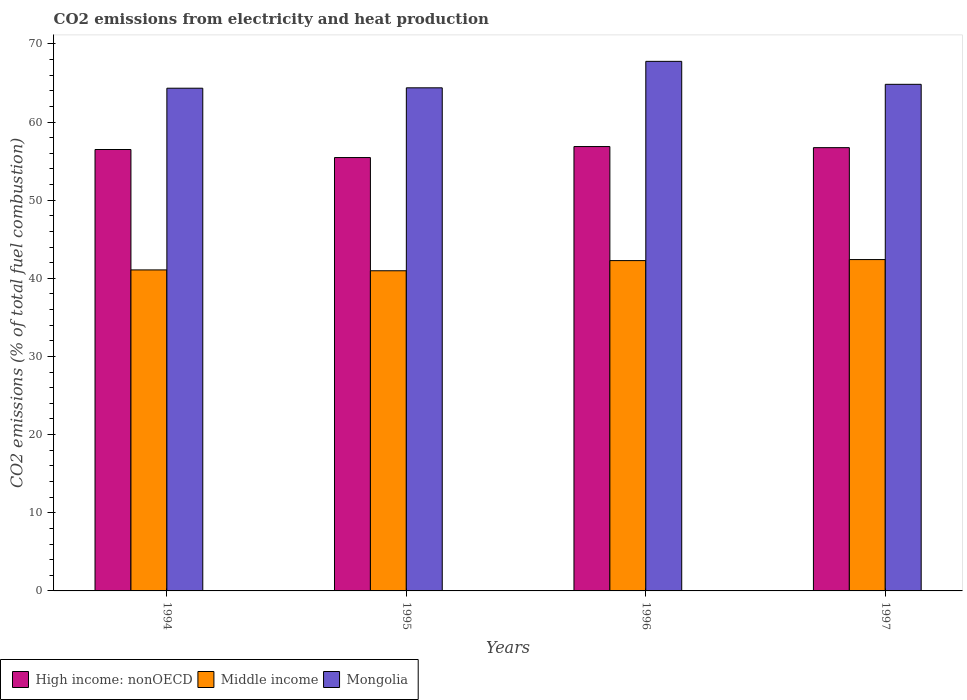Are the number of bars per tick equal to the number of legend labels?
Provide a short and direct response. Yes. Are the number of bars on each tick of the X-axis equal?
Provide a succinct answer. Yes. How many bars are there on the 2nd tick from the right?
Provide a succinct answer. 3. What is the label of the 1st group of bars from the left?
Give a very brief answer. 1994. In how many cases, is the number of bars for a given year not equal to the number of legend labels?
Your answer should be compact. 0. What is the amount of CO2 emitted in High income: nonOECD in 1997?
Give a very brief answer. 56.72. Across all years, what is the maximum amount of CO2 emitted in Mongolia?
Give a very brief answer. 67.76. Across all years, what is the minimum amount of CO2 emitted in Mongolia?
Give a very brief answer. 64.33. What is the total amount of CO2 emitted in Middle income in the graph?
Your response must be concise. 166.72. What is the difference between the amount of CO2 emitted in Middle income in 1994 and that in 1996?
Your answer should be compact. -1.19. What is the difference between the amount of CO2 emitted in High income: nonOECD in 1996 and the amount of CO2 emitted in Mongolia in 1995?
Give a very brief answer. -7.52. What is the average amount of CO2 emitted in Middle income per year?
Offer a very short reply. 41.68. In the year 1995, what is the difference between the amount of CO2 emitted in High income: nonOECD and amount of CO2 emitted in Mongolia?
Provide a short and direct response. -8.92. What is the ratio of the amount of CO2 emitted in Middle income in 1994 to that in 1996?
Offer a terse response. 0.97. Is the amount of CO2 emitted in Middle income in 1994 less than that in 1995?
Your answer should be compact. No. Is the difference between the amount of CO2 emitted in High income: nonOECD in 1995 and 1997 greater than the difference between the amount of CO2 emitted in Mongolia in 1995 and 1997?
Offer a terse response. No. What is the difference between the highest and the second highest amount of CO2 emitted in Middle income?
Offer a terse response. 0.13. What is the difference between the highest and the lowest amount of CO2 emitted in Middle income?
Give a very brief answer. 1.43. Is the sum of the amount of CO2 emitted in High income: nonOECD in 1996 and 1997 greater than the maximum amount of CO2 emitted in Middle income across all years?
Give a very brief answer. Yes. What does the 1st bar from the left in 1996 represents?
Your answer should be compact. High income: nonOECD. What does the 3rd bar from the right in 1997 represents?
Ensure brevity in your answer.  High income: nonOECD. What is the difference between two consecutive major ticks on the Y-axis?
Give a very brief answer. 10. Does the graph contain any zero values?
Your response must be concise. No. Does the graph contain grids?
Ensure brevity in your answer.  No. Where does the legend appear in the graph?
Your answer should be very brief. Bottom left. How are the legend labels stacked?
Offer a terse response. Horizontal. What is the title of the graph?
Offer a very short reply. CO2 emissions from electricity and heat production. Does "Macao" appear as one of the legend labels in the graph?
Provide a succinct answer. No. What is the label or title of the Y-axis?
Offer a very short reply. CO2 emissions (% of total fuel combustion). What is the CO2 emissions (% of total fuel combustion) of High income: nonOECD in 1994?
Keep it short and to the point. 56.48. What is the CO2 emissions (% of total fuel combustion) of Middle income in 1994?
Provide a succinct answer. 41.08. What is the CO2 emissions (% of total fuel combustion) of Mongolia in 1994?
Provide a succinct answer. 64.33. What is the CO2 emissions (% of total fuel combustion) in High income: nonOECD in 1995?
Make the answer very short. 55.45. What is the CO2 emissions (% of total fuel combustion) of Middle income in 1995?
Your response must be concise. 40.97. What is the CO2 emissions (% of total fuel combustion) of Mongolia in 1995?
Provide a succinct answer. 64.38. What is the CO2 emissions (% of total fuel combustion) of High income: nonOECD in 1996?
Offer a very short reply. 56.86. What is the CO2 emissions (% of total fuel combustion) in Middle income in 1996?
Your answer should be compact. 42.27. What is the CO2 emissions (% of total fuel combustion) in Mongolia in 1996?
Keep it short and to the point. 67.76. What is the CO2 emissions (% of total fuel combustion) of High income: nonOECD in 1997?
Ensure brevity in your answer.  56.72. What is the CO2 emissions (% of total fuel combustion) of Middle income in 1997?
Offer a terse response. 42.4. What is the CO2 emissions (% of total fuel combustion) in Mongolia in 1997?
Ensure brevity in your answer.  64.83. Across all years, what is the maximum CO2 emissions (% of total fuel combustion) in High income: nonOECD?
Your response must be concise. 56.86. Across all years, what is the maximum CO2 emissions (% of total fuel combustion) in Middle income?
Your response must be concise. 42.4. Across all years, what is the maximum CO2 emissions (% of total fuel combustion) of Mongolia?
Your answer should be compact. 67.76. Across all years, what is the minimum CO2 emissions (% of total fuel combustion) of High income: nonOECD?
Your response must be concise. 55.45. Across all years, what is the minimum CO2 emissions (% of total fuel combustion) in Middle income?
Make the answer very short. 40.97. Across all years, what is the minimum CO2 emissions (% of total fuel combustion) of Mongolia?
Offer a very short reply. 64.33. What is the total CO2 emissions (% of total fuel combustion) of High income: nonOECD in the graph?
Make the answer very short. 225.52. What is the total CO2 emissions (% of total fuel combustion) in Middle income in the graph?
Make the answer very short. 166.72. What is the total CO2 emissions (% of total fuel combustion) of Mongolia in the graph?
Offer a very short reply. 261.3. What is the difference between the CO2 emissions (% of total fuel combustion) of High income: nonOECD in 1994 and that in 1995?
Your answer should be compact. 1.03. What is the difference between the CO2 emissions (% of total fuel combustion) of Middle income in 1994 and that in 1995?
Your answer should be very brief. 0.11. What is the difference between the CO2 emissions (% of total fuel combustion) in High income: nonOECD in 1994 and that in 1996?
Provide a short and direct response. -0.38. What is the difference between the CO2 emissions (% of total fuel combustion) of Middle income in 1994 and that in 1996?
Ensure brevity in your answer.  -1.19. What is the difference between the CO2 emissions (% of total fuel combustion) in Mongolia in 1994 and that in 1996?
Keep it short and to the point. -3.44. What is the difference between the CO2 emissions (% of total fuel combustion) of High income: nonOECD in 1994 and that in 1997?
Provide a succinct answer. -0.24. What is the difference between the CO2 emissions (% of total fuel combustion) in Middle income in 1994 and that in 1997?
Make the answer very short. -1.32. What is the difference between the CO2 emissions (% of total fuel combustion) in Mongolia in 1994 and that in 1997?
Give a very brief answer. -0.5. What is the difference between the CO2 emissions (% of total fuel combustion) in High income: nonOECD in 1995 and that in 1996?
Provide a succinct answer. -1.41. What is the difference between the CO2 emissions (% of total fuel combustion) in Middle income in 1995 and that in 1996?
Provide a succinct answer. -1.3. What is the difference between the CO2 emissions (% of total fuel combustion) in Mongolia in 1995 and that in 1996?
Make the answer very short. -3.39. What is the difference between the CO2 emissions (% of total fuel combustion) of High income: nonOECD in 1995 and that in 1997?
Your answer should be very brief. -1.27. What is the difference between the CO2 emissions (% of total fuel combustion) in Middle income in 1995 and that in 1997?
Your answer should be very brief. -1.43. What is the difference between the CO2 emissions (% of total fuel combustion) of Mongolia in 1995 and that in 1997?
Your response must be concise. -0.45. What is the difference between the CO2 emissions (% of total fuel combustion) of High income: nonOECD in 1996 and that in 1997?
Ensure brevity in your answer.  0.14. What is the difference between the CO2 emissions (% of total fuel combustion) of Middle income in 1996 and that in 1997?
Give a very brief answer. -0.13. What is the difference between the CO2 emissions (% of total fuel combustion) of Mongolia in 1996 and that in 1997?
Offer a very short reply. 2.94. What is the difference between the CO2 emissions (% of total fuel combustion) of High income: nonOECD in 1994 and the CO2 emissions (% of total fuel combustion) of Middle income in 1995?
Provide a short and direct response. 15.52. What is the difference between the CO2 emissions (% of total fuel combustion) in High income: nonOECD in 1994 and the CO2 emissions (% of total fuel combustion) in Mongolia in 1995?
Ensure brevity in your answer.  -7.89. What is the difference between the CO2 emissions (% of total fuel combustion) in Middle income in 1994 and the CO2 emissions (% of total fuel combustion) in Mongolia in 1995?
Your answer should be compact. -23.3. What is the difference between the CO2 emissions (% of total fuel combustion) in High income: nonOECD in 1994 and the CO2 emissions (% of total fuel combustion) in Middle income in 1996?
Provide a succinct answer. 14.21. What is the difference between the CO2 emissions (% of total fuel combustion) of High income: nonOECD in 1994 and the CO2 emissions (% of total fuel combustion) of Mongolia in 1996?
Give a very brief answer. -11.28. What is the difference between the CO2 emissions (% of total fuel combustion) in Middle income in 1994 and the CO2 emissions (% of total fuel combustion) in Mongolia in 1996?
Make the answer very short. -26.69. What is the difference between the CO2 emissions (% of total fuel combustion) in High income: nonOECD in 1994 and the CO2 emissions (% of total fuel combustion) in Middle income in 1997?
Your answer should be very brief. 14.08. What is the difference between the CO2 emissions (% of total fuel combustion) of High income: nonOECD in 1994 and the CO2 emissions (% of total fuel combustion) of Mongolia in 1997?
Give a very brief answer. -8.34. What is the difference between the CO2 emissions (% of total fuel combustion) in Middle income in 1994 and the CO2 emissions (% of total fuel combustion) in Mongolia in 1997?
Ensure brevity in your answer.  -23.75. What is the difference between the CO2 emissions (% of total fuel combustion) of High income: nonOECD in 1995 and the CO2 emissions (% of total fuel combustion) of Middle income in 1996?
Give a very brief answer. 13.19. What is the difference between the CO2 emissions (% of total fuel combustion) of High income: nonOECD in 1995 and the CO2 emissions (% of total fuel combustion) of Mongolia in 1996?
Your answer should be compact. -12.31. What is the difference between the CO2 emissions (% of total fuel combustion) in Middle income in 1995 and the CO2 emissions (% of total fuel combustion) in Mongolia in 1996?
Ensure brevity in your answer.  -26.8. What is the difference between the CO2 emissions (% of total fuel combustion) in High income: nonOECD in 1995 and the CO2 emissions (% of total fuel combustion) in Middle income in 1997?
Provide a short and direct response. 13.05. What is the difference between the CO2 emissions (% of total fuel combustion) in High income: nonOECD in 1995 and the CO2 emissions (% of total fuel combustion) in Mongolia in 1997?
Your answer should be compact. -9.37. What is the difference between the CO2 emissions (% of total fuel combustion) in Middle income in 1995 and the CO2 emissions (% of total fuel combustion) in Mongolia in 1997?
Your response must be concise. -23.86. What is the difference between the CO2 emissions (% of total fuel combustion) in High income: nonOECD in 1996 and the CO2 emissions (% of total fuel combustion) in Middle income in 1997?
Keep it short and to the point. 14.46. What is the difference between the CO2 emissions (% of total fuel combustion) in High income: nonOECD in 1996 and the CO2 emissions (% of total fuel combustion) in Mongolia in 1997?
Give a very brief answer. -7.96. What is the difference between the CO2 emissions (% of total fuel combustion) in Middle income in 1996 and the CO2 emissions (% of total fuel combustion) in Mongolia in 1997?
Provide a succinct answer. -22.56. What is the average CO2 emissions (% of total fuel combustion) in High income: nonOECD per year?
Offer a very short reply. 56.38. What is the average CO2 emissions (% of total fuel combustion) of Middle income per year?
Offer a very short reply. 41.68. What is the average CO2 emissions (% of total fuel combustion) in Mongolia per year?
Provide a short and direct response. 65.32. In the year 1994, what is the difference between the CO2 emissions (% of total fuel combustion) of High income: nonOECD and CO2 emissions (% of total fuel combustion) of Middle income?
Make the answer very short. 15.41. In the year 1994, what is the difference between the CO2 emissions (% of total fuel combustion) of High income: nonOECD and CO2 emissions (% of total fuel combustion) of Mongolia?
Keep it short and to the point. -7.84. In the year 1994, what is the difference between the CO2 emissions (% of total fuel combustion) of Middle income and CO2 emissions (% of total fuel combustion) of Mongolia?
Give a very brief answer. -23.25. In the year 1995, what is the difference between the CO2 emissions (% of total fuel combustion) in High income: nonOECD and CO2 emissions (% of total fuel combustion) in Middle income?
Keep it short and to the point. 14.49. In the year 1995, what is the difference between the CO2 emissions (% of total fuel combustion) of High income: nonOECD and CO2 emissions (% of total fuel combustion) of Mongolia?
Provide a succinct answer. -8.92. In the year 1995, what is the difference between the CO2 emissions (% of total fuel combustion) of Middle income and CO2 emissions (% of total fuel combustion) of Mongolia?
Your answer should be compact. -23.41. In the year 1996, what is the difference between the CO2 emissions (% of total fuel combustion) in High income: nonOECD and CO2 emissions (% of total fuel combustion) in Middle income?
Your answer should be compact. 14.59. In the year 1996, what is the difference between the CO2 emissions (% of total fuel combustion) of High income: nonOECD and CO2 emissions (% of total fuel combustion) of Mongolia?
Keep it short and to the point. -10.9. In the year 1996, what is the difference between the CO2 emissions (% of total fuel combustion) in Middle income and CO2 emissions (% of total fuel combustion) in Mongolia?
Keep it short and to the point. -25.5. In the year 1997, what is the difference between the CO2 emissions (% of total fuel combustion) in High income: nonOECD and CO2 emissions (% of total fuel combustion) in Middle income?
Provide a succinct answer. 14.32. In the year 1997, what is the difference between the CO2 emissions (% of total fuel combustion) in High income: nonOECD and CO2 emissions (% of total fuel combustion) in Mongolia?
Your answer should be compact. -8.1. In the year 1997, what is the difference between the CO2 emissions (% of total fuel combustion) of Middle income and CO2 emissions (% of total fuel combustion) of Mongolia?
Provide a short and direct response. -22.43. What is the ratio of the CO2 emissions (% of total fuel combustion) in High income: nonOECD in 1994 to that in 1995?
Ensure brevity in your answer.  1.02. What is the ratio of the CO2 emissions (% of total fuel combustion) of Middle income in 1994 to that in 1995?
Ensure brevity in your answer.  1. What is the ratio of the CO2 emissions (% of total fuel combustion) of Mongolia in 1994 to that in 1995?
Make the answer very short. 1. What is the ratio of the CO2 emissions (% of total fuel combustion) in Middle income in 1994 to that in 1996?
Offer a very short reply. 0.97. What is the ratio of the CO2 emissions (% of total fuel combustion) of Mongolia in 1994 to that in 1996?
Offer a terse response. 0.95. What is the ratio of the CO2 emissions (% of total fuel combustion) of High income: nonOECD in 1994 to that in 1997?
Your response must be concise. 1. What is the ratio of the CO2 emissions (% of total fuel combustion) in Middle income in 1994 to that in 1997?
Give a very brief answer. 0.97. What is the ratio of the CO2 emissions (% of total fuel combustion) in Mongolia in 1994 to that in 1997?
Provide a succinct answer. 0.99. What is the ratio of the CO2 emissions (% of total fuel combustion) in High income: nonOECD in 1995 to that in 1996?
Provide a succinct answer. 0.98. What is the ratio of the CO2 emissions (% of total fuel combustion) in Middle income in 1995 to that in 1996?
Your answer should be compact. 0.97. What is the ratio of the CO2 emissions (% of total fuel combustion) of High income: nonOECD in 1995 to that in 1997?
Provide a succinct answer. 0.98. What is the ratio of the CO2 emissions (% of total fuel combustion) of Middle income in 1995 to that in 1997?
Make the answer very short. 0.97. What is the ratio of the CO2 emissions (% of total fuel combustion) of Mongolia in 1996 to that in 1997?
Provide a succinct answer. 1.05. What is the difference between the highest and the second highest CO2 emissions (% of total fuel combustion) of High income: nonOECD?
Offer a very short reply. 0.14. What is the difference between the highest and the second highest CO2 emissions (% of total fuel combustion) in Middle income?
Provide a succinct answer. 0.13. What is the difference between the highest and the second highest CO2 emissions (% of total fuel combustion) in Mongolia?
Your answer should be compact. 2.94. What is the difference between the highest and the lowest CO2 emissions (% of total fuel combustion) in High income: nonOECD?
Provide a succinct answer. 1.41. What is the difference between the highest and the lowest CO2 emissions (% of total fuel combustion) of Middle income?
Ensure brevity in your answer.  1.43. What is the difference between the highest and the lowest CO2 emissions (% of total fuel combustion) in Mongolia?
Ensure brevity in your answer.  3.44. 